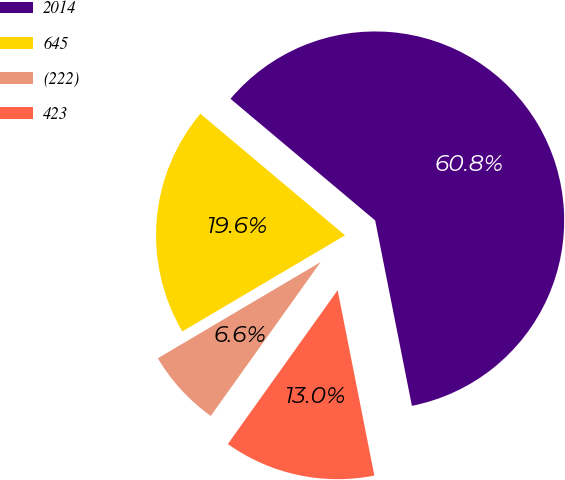Convert chart. <chart><loc_0><loc_0><loc_500><loc_500><pie_chart><fcel>2014<fcel>645<fcel>(222)<fcel>423<nl><fcel>60.76%<fcel>19.62%<fcel>6.64%<fcel>12.98%<nl></chart> 